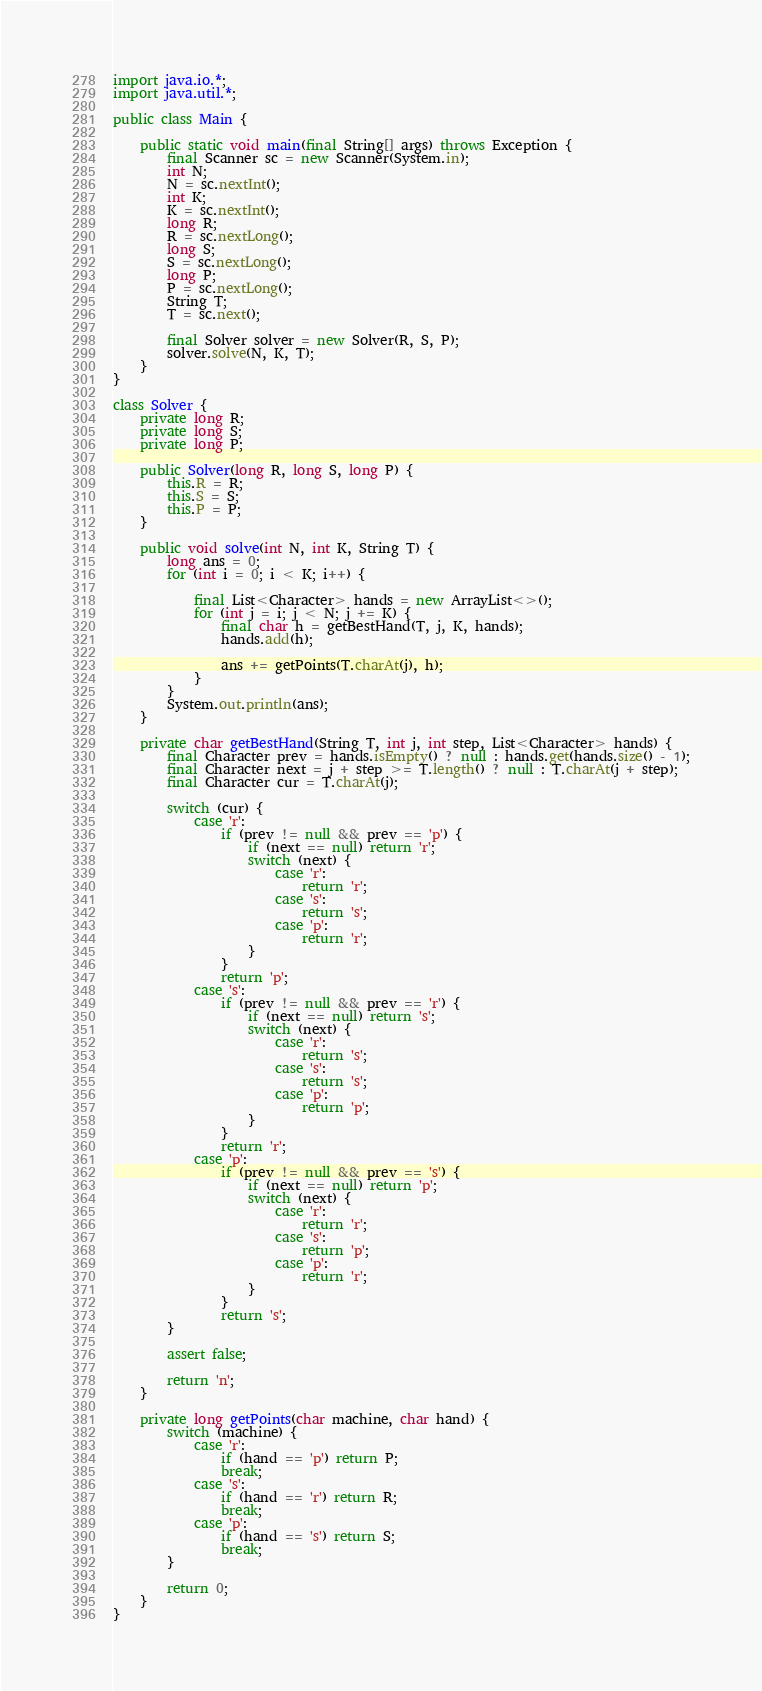Convert code to text. <code><loc_0><loc_0><loc_500><loc_500><_Java_>import java.io.*;
import java.util.*;

public class Main {

    public static void main(final String[] args) throws Exception {
        final Scanner sc = new Scanner(System.in);
        int N;
        N = sc.nextInt();
        int K;
        K = sc.nextInt();
        long R;
        R = sc.nextLong();
        long S;
        S = sc.nextLong();
        long P;
        P = sc.nextLong();
        String T;
        T = sc.next();

        final Solver solver = new Solver(R, S, P);
        solver.solve(N, K, T);
    }
}

class Solver {
    private long R;
    private long S;
    private long P;

    public Solver(long R, long S, long P) {
        this.R = R;
        this.S = S;
        this.P = P;
    }

    public void solve(int N, int K, String T) {
        long ans = 0;
        for (int i = 0; i < K; i++) {

            final List<Character> hands = new ArrayList<>();
            for (int j = i; j < N; j += K) {
                final char h = getBestHand(T, j, K, hands);
                hands.add(h);

                ans += getPoints(T.charAt(j), h);
            }
        }
        System.out.println(ans);
    }

    private char getBestHand(String T, int j, int step, List<Character> hands) {
        final Character prev = hands.isEmpty() ? null : hands.get(hands.size() - 1);
        final Character next = j + step >= T.length() ? null : T.charAt(j + step);
        final Character cur = T.charAt(j);

        switch (cur) {
            case 'r':
                if (prev != null && prev == 'p') {
                    if (next == null) return 'r';
                    switch (next) {
                        case 'r':
                            return 'r';
                        case 's':
                            return 's';
                        case 'p':
                            return 'r';
                    }
                }
                return 'p';
            case 's':
                if (prev != null && prev == 'r') {
                    if (next == null) return 's';
                    switch (next) {
                        case 'r':
                            return 's';
                        case 's':
                            return 's';
                        case 'p':
                            return 'p';
                    }
                }
                return 'r';
            case 'p':
                if (prev != null && prev == 's') {
                    if (next == null) return 'p';
                    switch (next) {
                        case 'r':
                            return 'r';
                        case 's':
                            return 'p';
                        case 'p':
                            return 'r';
                    }
                }
                return 's';
        }

        assert false;

        return 'n';
    }

    private long getPoints(char machine, char hand) {
        switch (machine) {
            case 'r':
                if (hand == 'p') return P;
                break;
            case 's':
                if (hand == 'r') return R;
                break;
            case 'p':
                if (hand == 's') return S;
                break;
        }

        return 0;
    }
}

</code> 